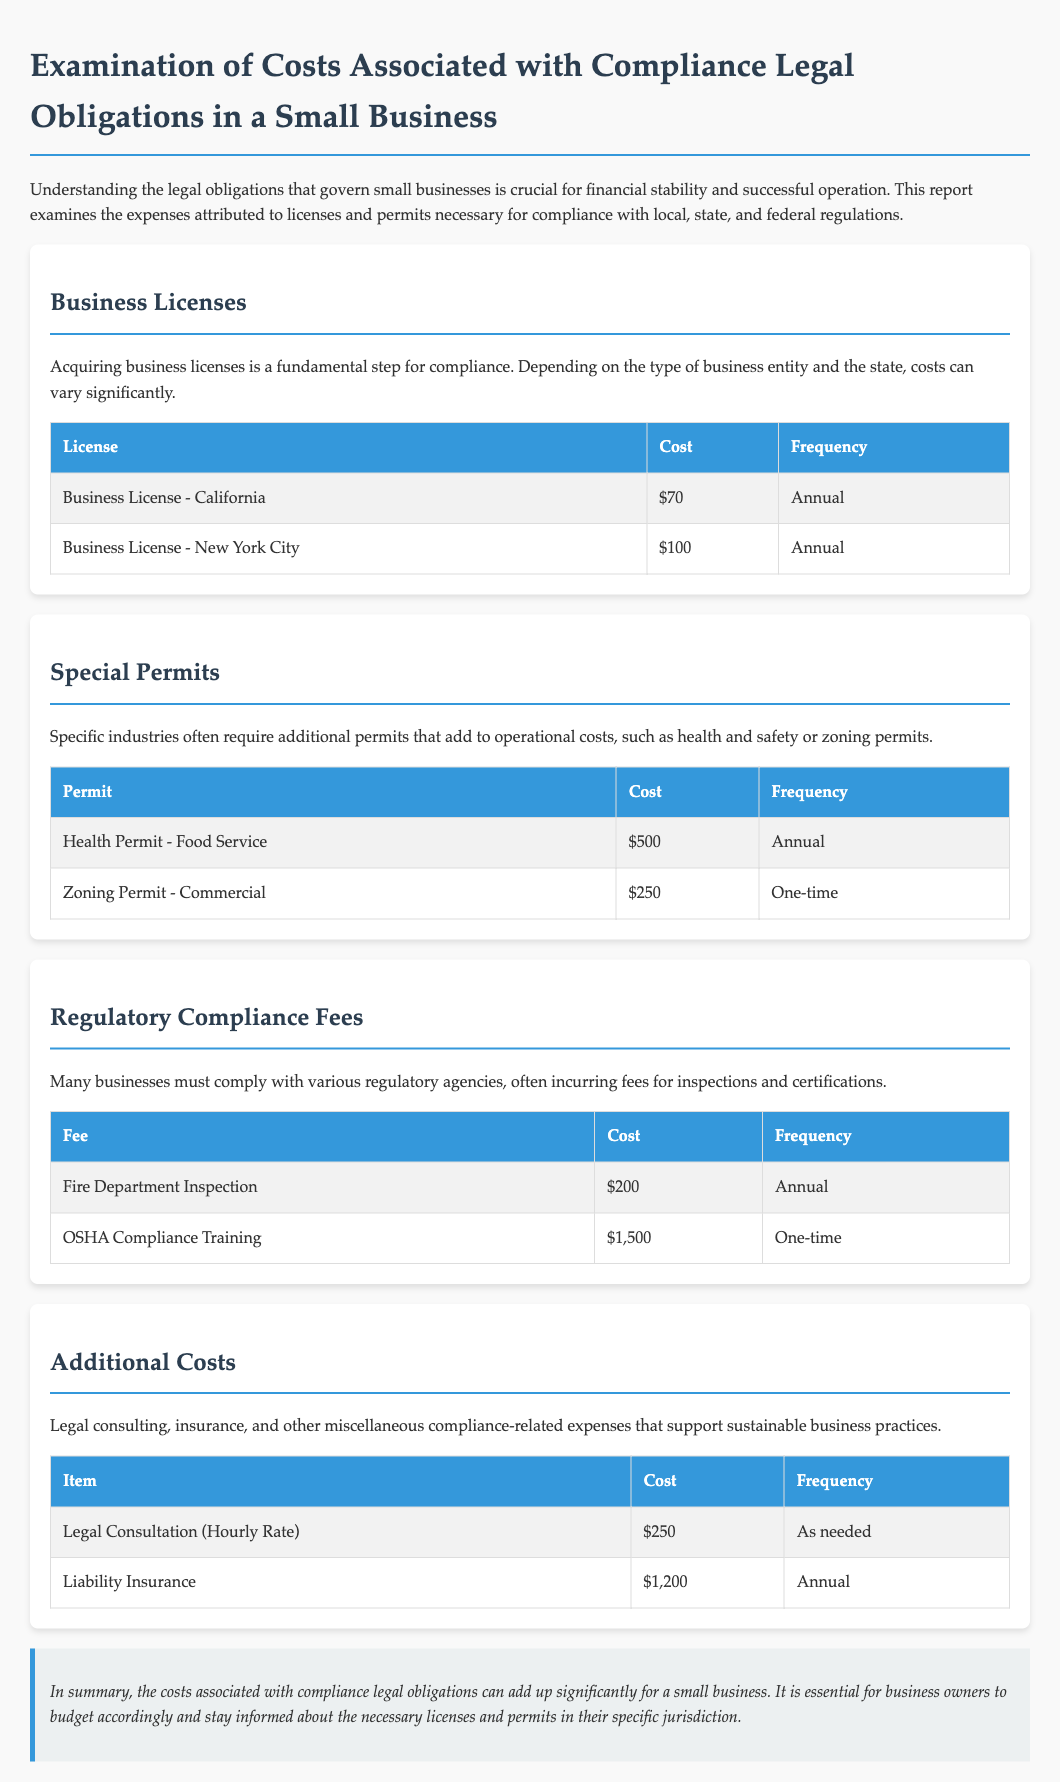What is the cost of a Business License in California? The cost of a Business License in California is mentioned in the table, which lists it as $70.
Answer: $70 How often is the Health Permit for Food Service required? The frequency for the Health Permit - Food Service is specified in the document as Annual.
Answer: Annual What is the one-time cost for a Zoning Permit? The document indicates that the one-time cost for a Zoning Permit - Commercial is $250.
Answer: $250 What is the total cost for licenses listed in the document? The total cost for licenses is derived from the Business License costs in the table: $70 (California) + $100 (New York City) = $170.
Answer: $170 How much does OSHA Compliance Training cost? The document specifies that the cost for OSHA Compliance Training is $1,500.
Answer: $1,500 What type of insurance is mentioned in the Additional Costs section? The document refers to Liability Insurance as the type of insurance associated with Additional Costs.
Answer: Liability Insurance What is the hourly rate for Legal Consultation? The hourly rate for Legal Consultation is detailed in the document as $250.
Answer: $250 What annual regulatory compliance fee is noted in the document? The document lists the Fire Department Inspection as an annual regulatory compliance fee of $200.
Answer: $200 What is the total cost of all fees listed in the Regulatory Compliance section? The total cost is the sum of the two fees: $200 (Fire Department Inspection) + $1,500 (OSHA Compliance Training) = $1,700.
Answer: $1,700 